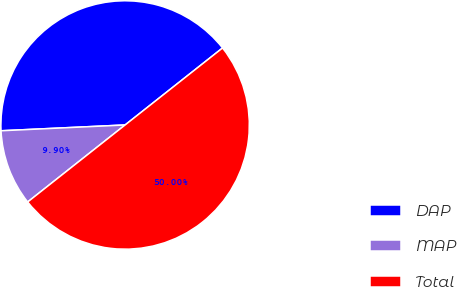Convert chart to OTSL. <chart><loc_0><loc_0><loc_500><loc_500><pie_chart><fcel>DAP<fcel>MAP<fcel>Total<nl><fcel>40.1%<fcel>9.9%<fcel>50.0%<nl></chart> 